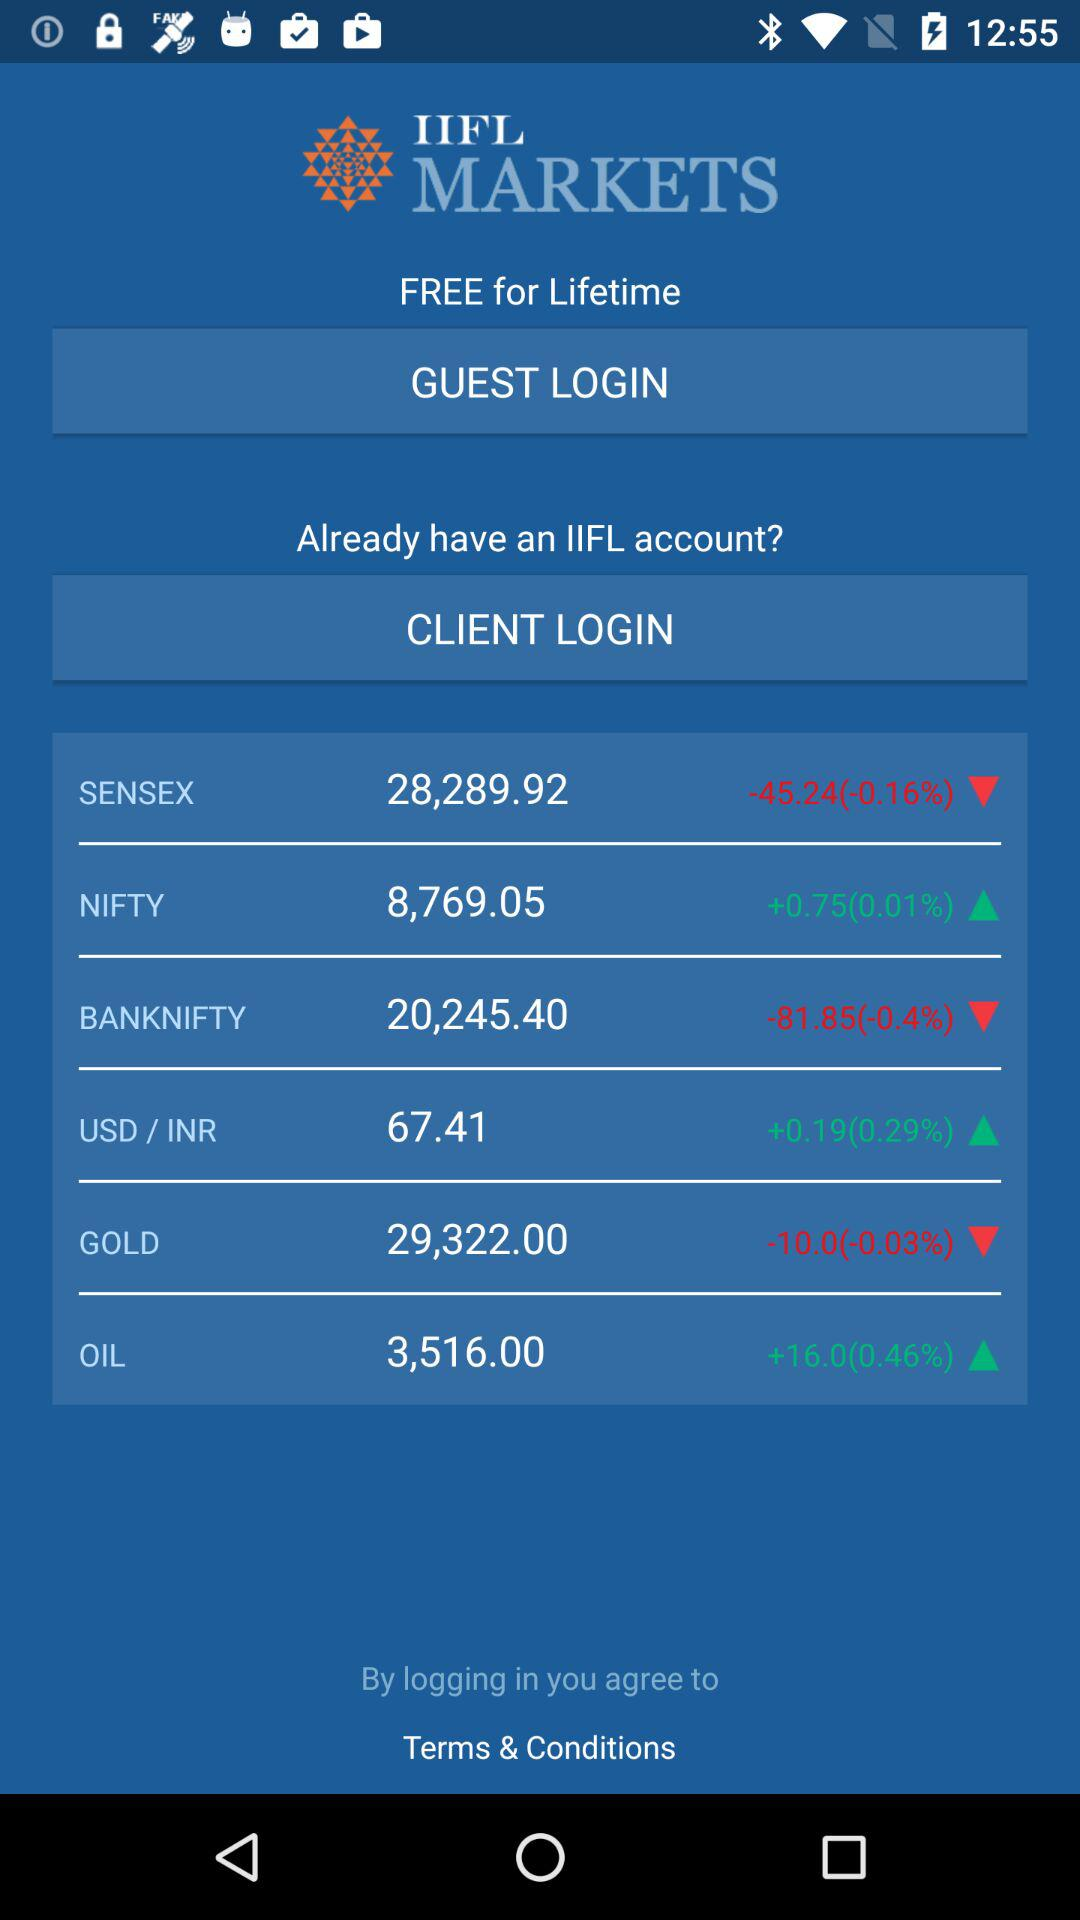What is the application name? The application name is "IIFL MARKETS". 